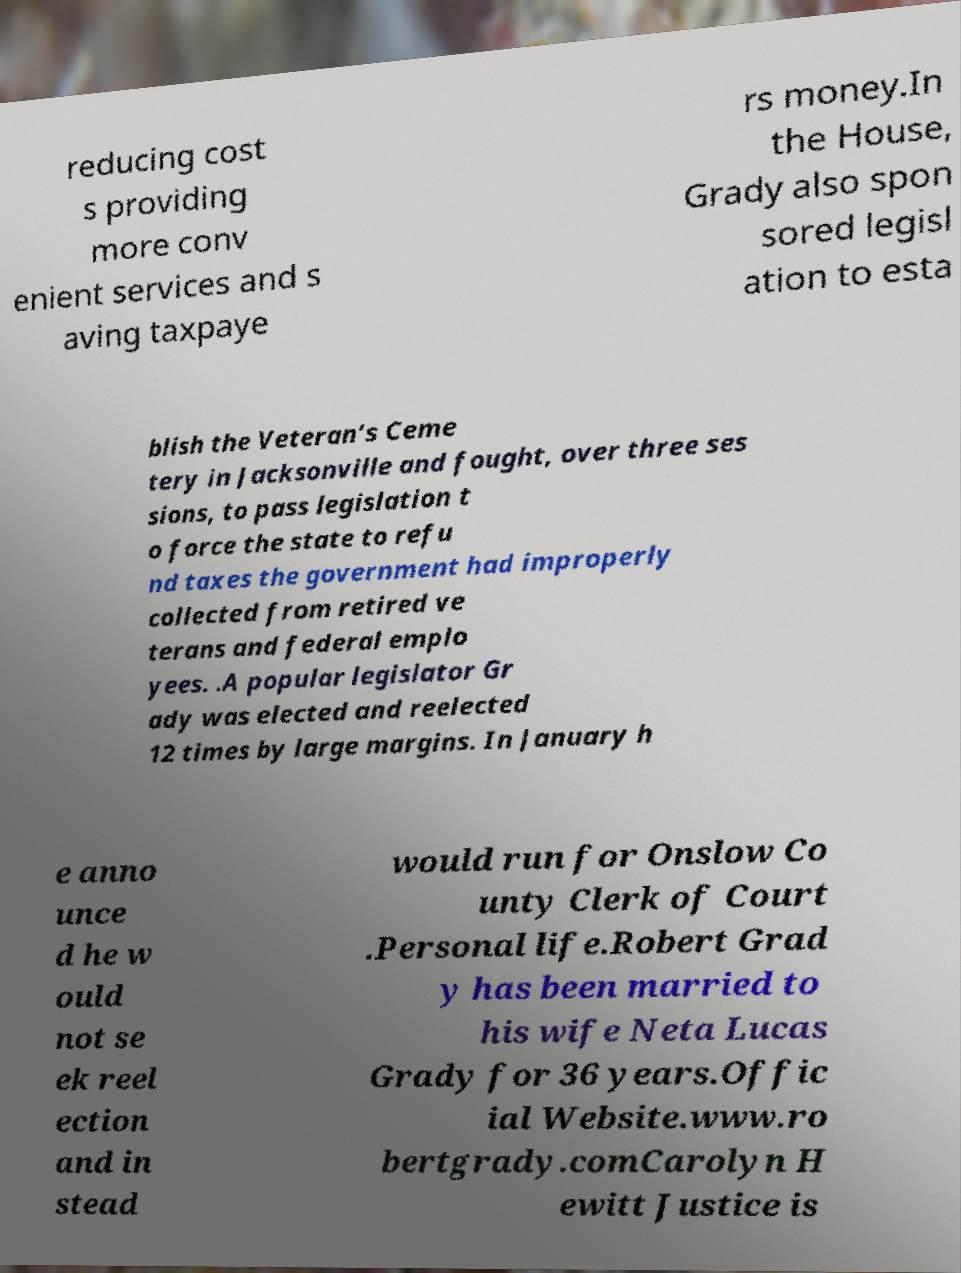Can you accurately transcribe the text from the provided image for me? reducing cost s providing more conv enient services and s aving taxpaye rs money.In the House, Grady also spon sored legisl ation to esta blish the Veteran’s Ceme tery in Jacksonville and fought, over three ses sions, to pass legislation t o force the state to refu nd taxes the government had improperly collected from retired ve terans and federal emplo yees. .A popular legislator Gr ady was elected and reelected 12 times by large margins. In January h e anno unce d he w ould not se ek reel ection and in stead would run for Onslow Co unty Clerk of Court .Personal life.Robert Grad y has been married to his wife Neta Lucas Grady for 36 years.Offic ial Website.www.ro bertgrady.comCarolyn H ewitt Justice is 